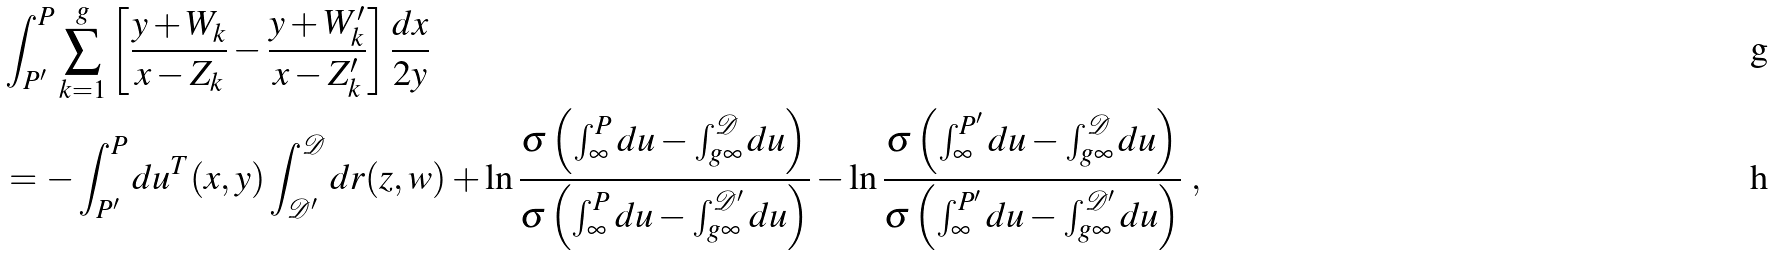Convert formula to latex. <formula><loc_0><loc_0><loc_500><loc_500>& \int _ { P ^ { \prime } } ^ { P } \sum _ { k = 1 } ^ { g } \left [ \frac { y + W _ { k } } { x - Z _ { k } } - \frac { y + W _ { k } ^ { \prime } } { x - Z _ { k } ^ { \prime } } \right ] \frac { d x } { 2 y } \\ & = - \int _ { P ^ { \prime } } ^ { P } d u ^ { T } ( x , y ) \int _ { \mathcal { D } ^ { \prime } } ^ { \mathcal { D } } d r ( z , w ) + \ln \frac { \sigma \left ( \int _ { \infty } ^ { P } d u - \int _ { g \infty } ^ { \mathcal { D } } d u \right ) } { \sigma \left ( \int _ { \infty } ^ { P } d u - \int _ { g \infty } ^ { \mathcal { D } ^ { \prime } } d u \right ) } - \ln \frac { \sigma \left ( \int _ { \infty } ^ { P ^ { \prime } } d u - \int _ { g \infty } ^ { \mathcal { D } } d u \right ) } { \sigma \left ( \int _ { \infty } ^ { P ^ { \prime } } d u - \int _ { g \infty } ^ { \mathcal { D } ^ { \prime } } d u \right ) } \ ,</formula> 